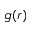<formula> <loc_0><loc_0><loc_500><loc_500>g ( r )</formula> 